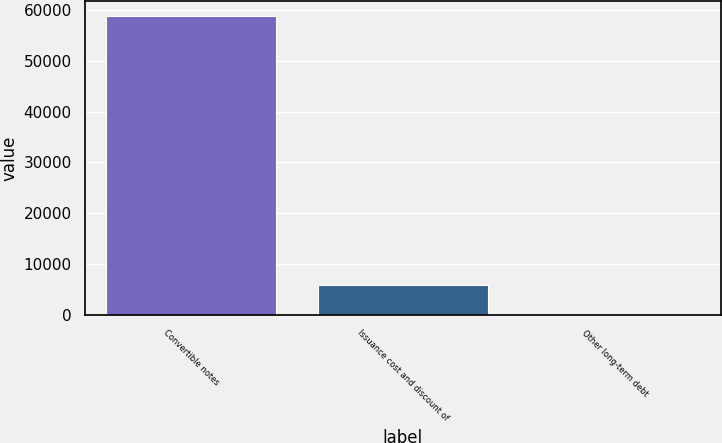Convert chart. <chart><loc_0><loc_0><loc_500><loc_500><bar_chart><fcel>Convertible notes<fcel>Issuance cost and discount of<fcel>Other long-term debt<nl><fcel>58782<fcel>5906.1<fcel>31<nl></chart> 